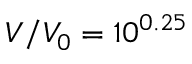<formula> <loc_0><loc_0><loc_500><loc_500>V / V _ { 0 } = 1 0 ^ { 0 . 2 5 }</formula> 